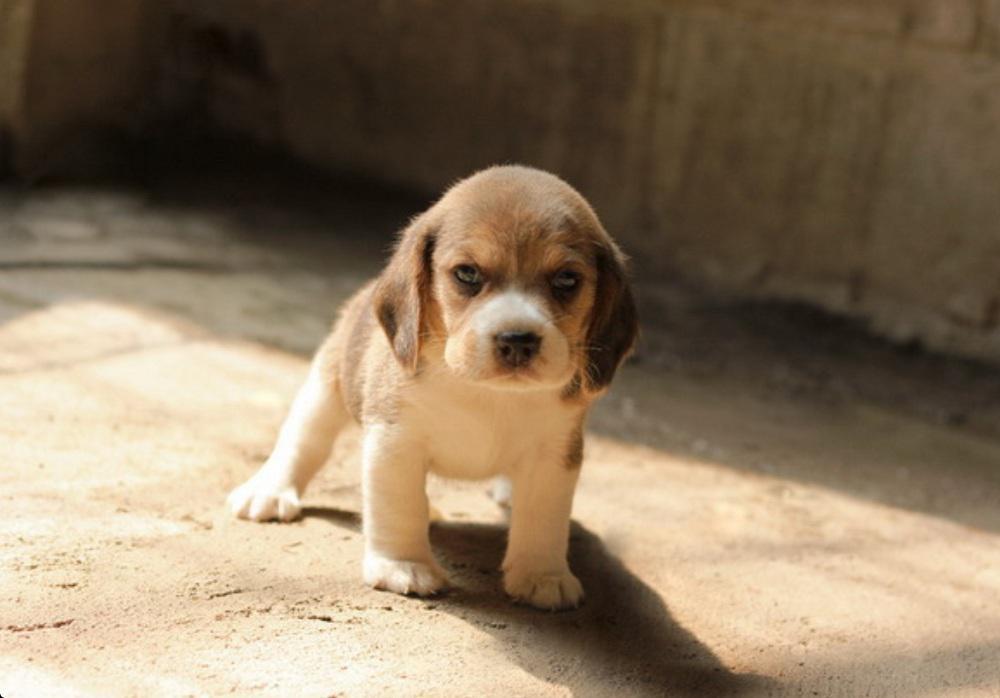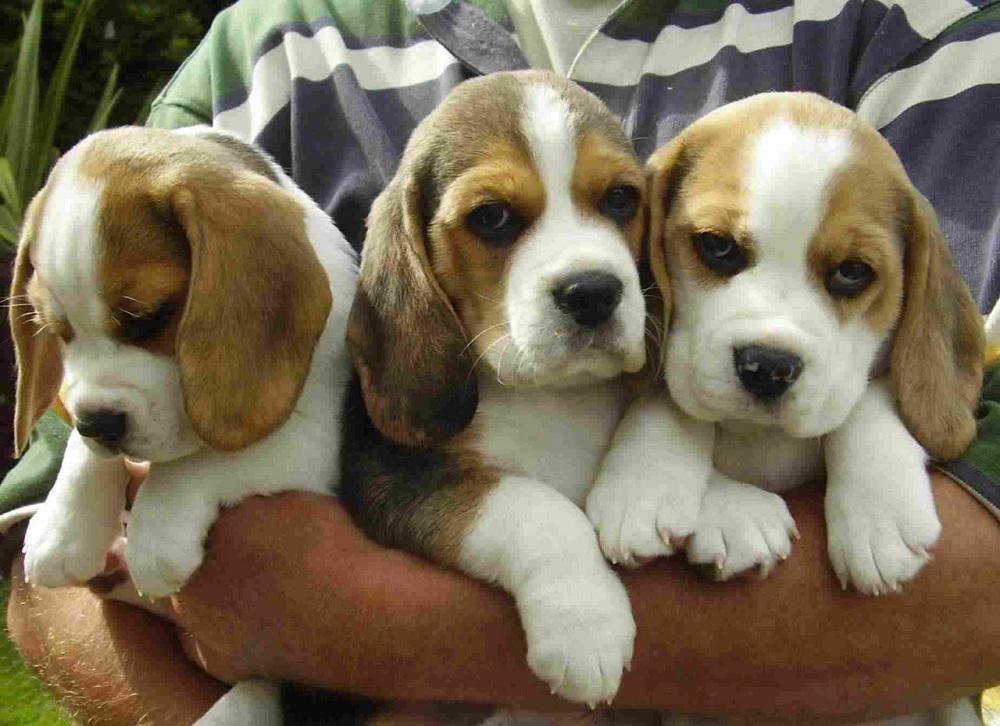The first image is the image on the left, the second image is the image on the right. Evaluate the accuracy of this statement regarding the images: "There are at most three dogs.". Is it true? Answer yes or no. No. 